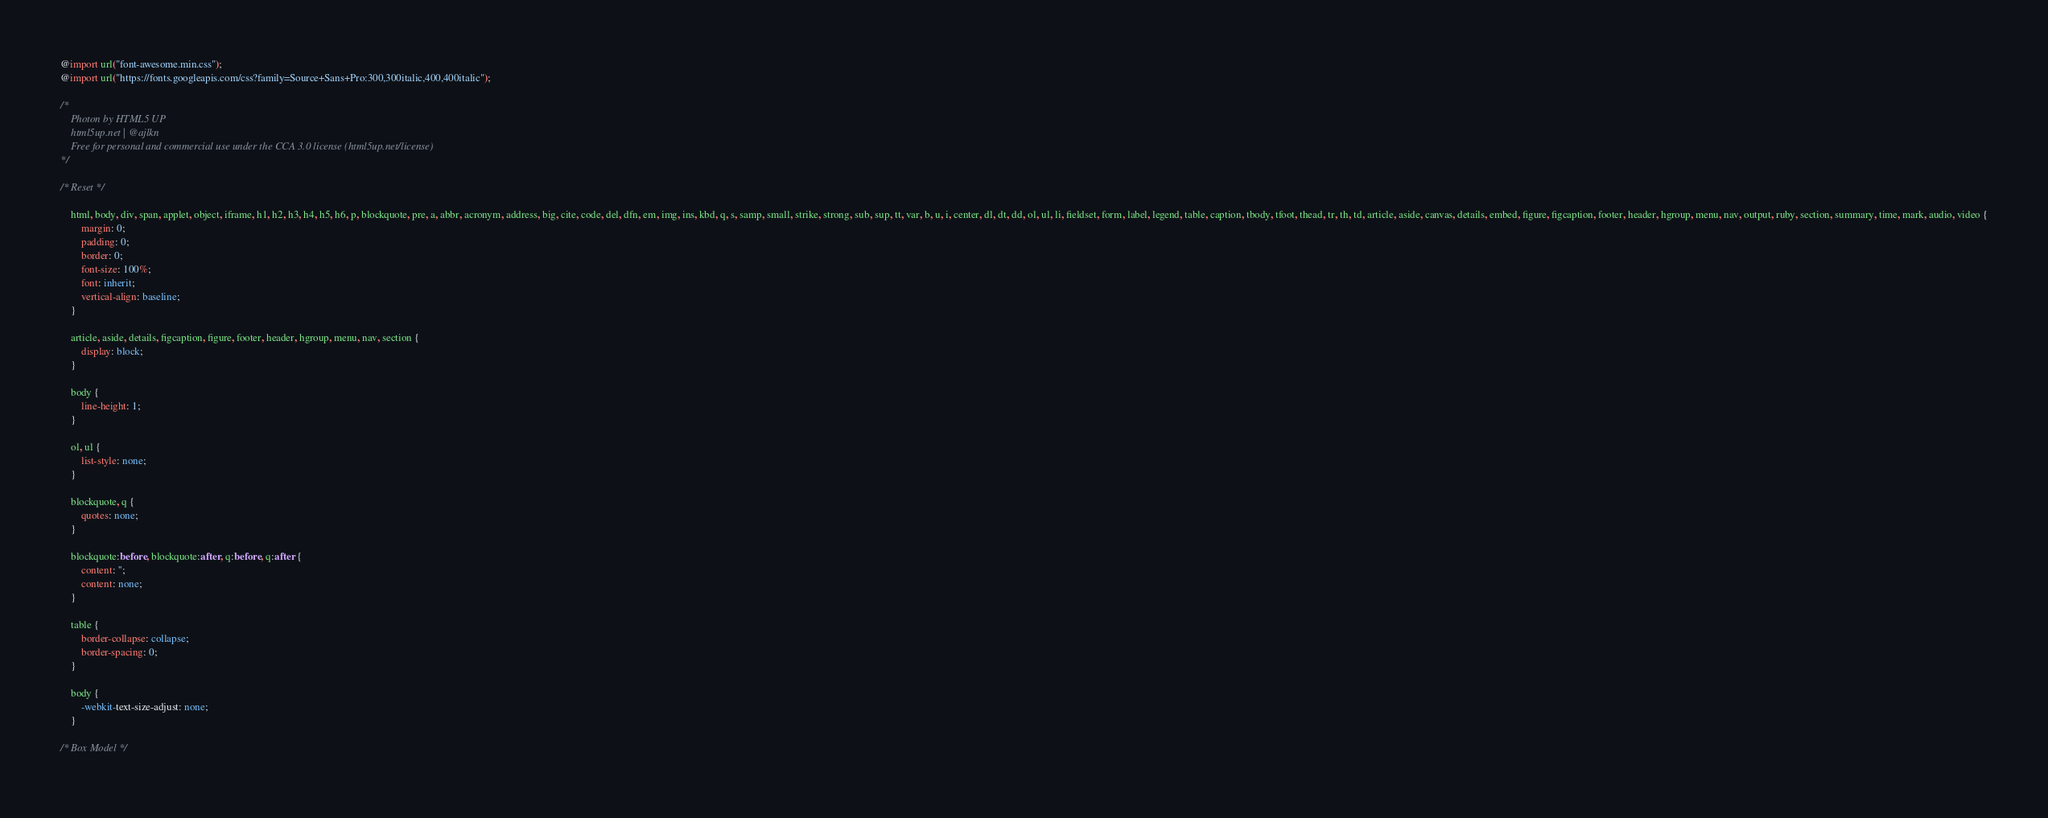Convert code to text. <code><loc_0><loc_0><loc_500><loc_500><_CSS_>@import url("font-awesome.min.css");
@import url("https://fonts.googleapis.com/css?family=Source+Sans+Pro:300,300italic,400,400italic");

/*
	Photon by HTML5 UP
	html5up.net | @ajlkn
	Free for personal and commercial use under the CCA 3.0 license (html5up.net/license)
*/

/* Reset */

	html, body, div, span, applet, object, iframe, h1, h2, h3, h4, h5, h6, p, blockquote, pre, a, abbr, acronym, address, big, cite, code, del, dfn, em, img, ins, kbd, q, s, samp, small, strike, strong, sub, sup, tt, var, b, u, i, center, dl, dt, dd, ol, ul, li, fieldset, form, label, legend, table, caption, tbody, tfoot, thead, tr, th, td, article, aside, canvas, details, embed, figure, figcaption, footer, header, hgroup, menu, nav, output, ruby, section, summary, time, mark, audio, video {
		margin: 0;
		padding: 0;
		border: 0;
		font-size: 100%;
		font: inherit;
		vertical-align: baseline;
	}

	article, aside, details, figcaption, figure, footer, header, hgroup, menu, nav, section {
		display: block;
	}

	body {
		line-height: 1;
	}

	ol, ul {
		list-style: none;
	}

	blockquote, q {
		quotes: none;
	}

	blockquote:before, blockquote:after, q:before, q:after {
		content: '';
		content: none;
	}

	table {
		border-collapse: collapse;
		border-spacing: 0;
	}

	body {
		-webkit-text-size-adjust: none;
	}

/* Box Model */
</code> 